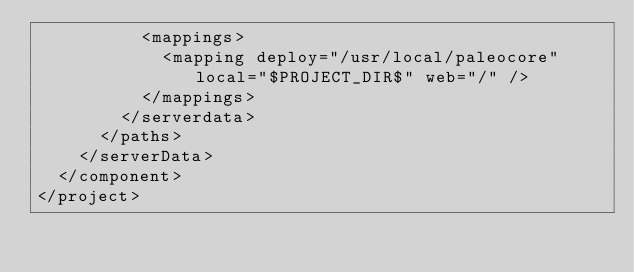Convert code to text. <code><loc_0><loc_0><loc_500><loc_500><_XML_>          <mappings>
            <mapping deploy="/usr/local/paleocore" local="$PROJECT_DIR$" web="/" />
          </mappings>
        </serverdata>
      </paths>
    </serverData>
  </component>
</project></code> 